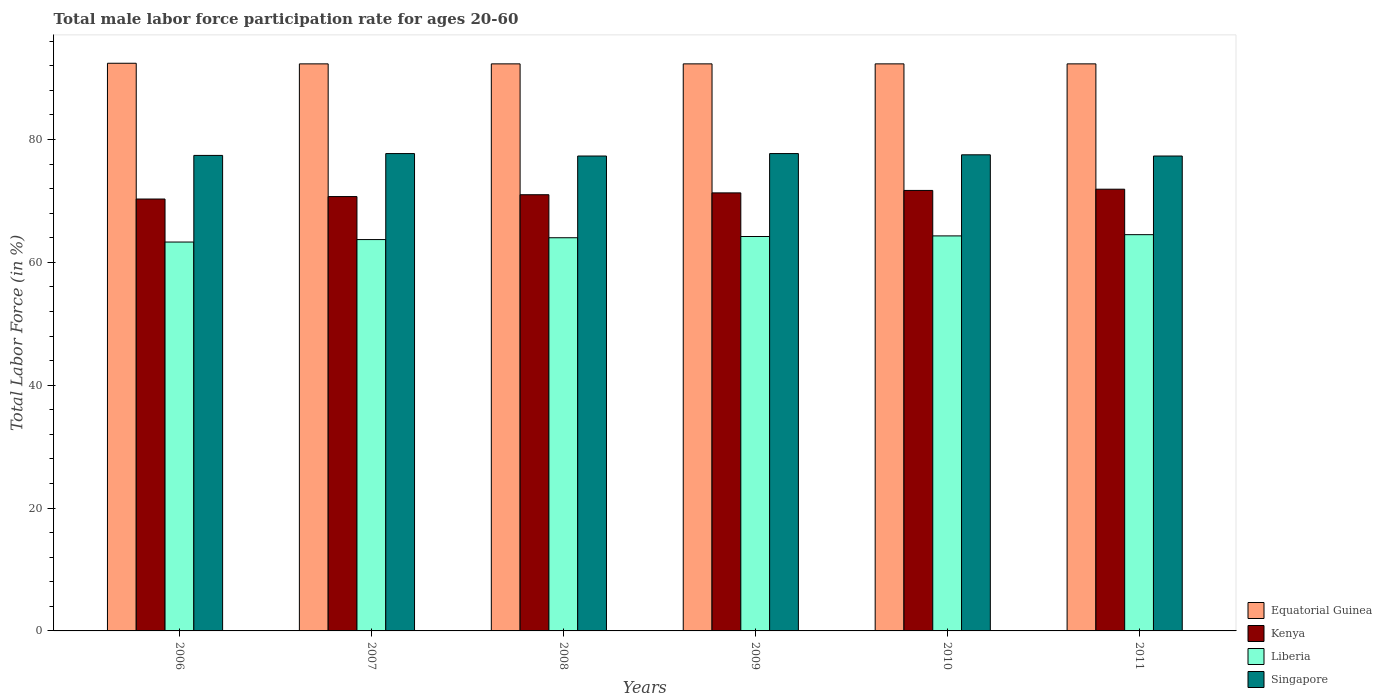How many groups of bars are there?
Keep it short and to the point. 6. Are the number of bars per tick equal to the number of legend labels?
Make the answer very short. Yes. What is the male labor force participation rate in Kenya in 2010?
Your response must be concise. 71.7. Across all years, what is the maximum male labor force participation rate in Kenya?
Keep it short and to the point. 71.9. Across all years, what is the minimum male labor force participation rate in Liberia?
Offer a very short reply. 63.3. In which year was the male labor force participation rate in Equatorial Guinea maximum?
Offer a terse response. 2006. In which year was the male labor force participation rate in Liberia minimum?
Your answer should be compact. 2006. What is the total male labor force participation rate in Kenya in the graph?
Offer a terse response. 426.9. What is the difference between the male labor force participation rate in Liberia in 2007 and the male labor force participation rate in Equatorial Guinea in 2010?
Your answer should be compact. -28.6. What is the average male labor force participation rate in Singapore per year?
Provide a succinct answer. 77.48. In the year 2006, what is the difference between the male labor force participation rate in Kenya and male labor force participation rate in Singapore?
Make the answer very short. -7.1. In how many years, is the male labor force participation rate in Singapore greater than 4 %?
Your answer should be very brief. 6. What is the ratio of the male labor force participation rate in Singapore in 2006 to that in 2011?
Make the answer very short. 1. Is the male labor force participation rate in Singapore in 2006 less than that in 2011?
Your response must be concise. No. Is the difference between the male labor force participation rate in Kenya in 2007 and 2010 greater than the difference between the male labor force participation rate in Singapore in 2007 and 2010?
Make the answer very short. No. What is the difference between the highest and the second highest male labor force participation rate in Equatorial Guinea?
Your response must be concise. 0.1. What is the difference between the highest and the lowest male labor force participation rate in Singapore?
Provide a short and direct response. 0.4. In how many years, is the male labor force participation rate in Singapore greater than the average male labor force participation rate in Singapore taken over all years?
Offer a very short reply. 3. What does the 3rd bar from the left in 2009 represents?
Give a very brief answer. Liberia. What does the 3rd bar from the right in 2007 represents?
Make the answer very short. Kenya. How many bars are there?
Your response must be concise. 24. What is the difference between two consecutive major ticks on the Y-axis?
Provide a short and direct response. 20. Does the graph contain any zero values?
Your answer should be compact. No. Does the graph contain grids?
Your answer should be compact. No. How many legend labels are there?
Provide a short and direct response. 4. How are the legend labels stacked?
Keep it short and to the point. Vertical. What is the title of the graph?
Ensure brevity in your answer.  Total male labor force participation rate for ages 20-60. Does "Tajikistan" appear as one of the legend labels in the graph?
Make the answer very short. No. What is the label or title of the Y-axis?
Keep it short and to the point. Total Labor Force (in %). What is the Total Labor Force (in %) in Equatorial Guinea in 2006?
Your answer should be very brief. 92.4. What is the Total Labor Force (in %) in Kenya in 2006?
Make the answer very short. 70.3. What is the Total Labor Force (in %) of Liberia in 2006?
Provide a short and direct response. 63.3. What is the Total Labor Force (in %) in Singapore in 2006?
Give a very brief answer. 77.4. What is the Total Labor Force (in %) in Equatorial Guinea in 2007?
Give a very brief answer. 92.3. What is the Total Labor Force (in %) in Kenya in 2007?
Your answer should be compact. 70.7. What is the Total Labor Force (in %) of Liberia in 2007?
Make the answer very short. 63.7. What is the Total Labor Force (in %) of Singapore in 2007?
Ensure brevity in your answer.  77.7. What is the Total Labor Force (in %) in Equatorial Guinea in 2008?
Provide a short and direct response. 92.3. What is the Total Labor Force (in %) in Liberia in 2008?
Make the answer very short. 64. What is the Total Labor Force (in %) in Singapore in 2008?
Offer a terse response. 77.3. What is the Total Labor Force (in %) in Equatorial Guinea in 2009?
Provide a short and direct response. 92.3. What is the Total Labor Force (in %) of Kenya in 2009?
Offer a terse response. 71.3. What is the Total Labor Force (in %) in Liberia in 2009?
Give a very brief answer. 64.2. What is the Total Labor Force (in %) of Singapore in 2009?
Your answer should be very brief. 77.7. What is the Total Labor Force (in %) of Equatorial Guinea in 2010?
Make the answer very short. 92.3. What is the Total Labor Force (in %) of Kenya in 2010?
Your answer should be very brief. 71.7. What is the Total Labor Force (in %) of Liberia in 2010?
Your answer should be very brief. 64.3. What is the Total Labor Force (in %) in Singapore in 2010?
Make the answer very short. 77.5. What is the Total Labor Force (in %) in Equatorial Guinea in 2011?
Make the answer very short. 92.3. What is the Total Labor Force (in %) of Kenya in 2011?
Your answer should be compact. 71.9. What is the Total Labor Force (in %) in Liberia in 2011?
Give a very brief answer. 64.5. What is the Total Labor Force (in %) in Singapore in 2011?
Make the answer very short. 77.3. Across all years, what is the maximum Total Labor Force (in %) in Equatorial Guinea?
Your response must be concise. 92.4. Across all years, what is the maximum Total Labor Force (in %) of Kenya?
Provide a succinct answer. 71.9. Across all years, what is the maximum Total Labor Force (in %) of Liberia?
Make the answer very short. 64.5. Across all years, what is the maximum Total Labor Force (in %) of Singapore?
Offer a very short reply. 77.7. Across all years, what is the minimum Total Labor Force (in %) of Equatorial Guinea?
Make the answer very short. 92.3. Across all years, what is the minimum Total Labor Force (in %) in Kenya?
Your answer should be compact. 70.3. Across all years, what is the minimum Total Labor Force (in %) in Liberia?
Provide a short and direct response. 63.3. Across all years, what is the minimum Total Labor Force (in %) of Singapore?
Keep it short and to the point. 77.3. What is the total Total Labor Force (in %) in Equatorial Guinea in the graph?
Your answer should be very brief. 553.9. What is the total Total Labor Force (in %) of Kenya in the graph?
Make the answer very short. 426.9. What is the total Total Labor Force (in %) of Liberia in the graph?
Your answer should be compact. 384. What is the total Total Labor Force (in %) in Singapore in the graph?
Make the answer very short. 464.9. What is the difference between the Total Labor Force (in %) in Liberia in 2006 and that in 2007?
Offer a terse response. -0.4. What is the difference between the Total Labor Force (in %) of Equatorial Guinea in 2006 and that in 2008?
Make the answer very short. 0.1. What is the difference between the Total Labor Force (in %) in Singapore in 2006 and that in 2008?
Make the answer very short. 0.1. What is the difference between the Total Labor Force (in %) in Liberia in 2006 and that in 2009?
Ensure brevity in your answer.  -0.9. What is the difference between the Total Labor Force (in %) in Kenya in 2006 and that in 2010?
Your answer should be very brief. -1.4. What is the difference between the Total Labor Force (in %) in Liberia in 2006 and that in 2010?
Offer a terse response. -1. What is the difference between the Total Labor Force (in %) of Equatorial Guinea in 2006 and that in 2011?
Give a very brief answer. 0.1. What is the difference between the Total Labor Force (in %) in Kenya in 2006 and that in 2011?
Keep it short and to the point. -1.6. What is the difference between the Total Labor Force (in %) of Liberia in 2006 and that in 2011?
Make the answer very short. -1.2. What is the difference between the Total Labor Force (in %) in Singapore in 2006 and that in 2011?
Your response must be concise. 0.1. What is the difference between the Total Labor Force (in %) of Equatorial Guinea in 2007 and that in 2008?
Your answer should be compact. 0. What is the difference between the Total Labor Force (in %) of Kenya in 2007 and that in 2008?
Offer a very short reply. -0.3. What is the difference between the Total Labor Force (in %) of Singapore in 2007 and that in 2009?
Make the answer very short. 0. What is the difference between the Total Labor Force (in %) of Equatorial Guinea in 2007 and that in 2011?
Offer a terse response. 0. What is the difference between the Total Labor Force (in %) in Singapore in 2007 and that in 2011?
Give a very brief answer. 0.4. What is the difference between the Total Labor Force (in %) in Kenya in 2008 and that in 2009?
Provide a short and direct response. -0.3. What is the difference between the Total Labor Force (in %) of Singapore in 2008 and that in 2009?
Offer a terse response. -0.4. What is the difference between the Total Labor Force (in %) of Kenya in 2008 and that in 2010?
Offer a very short reply. -0.7. What is the difference between the Total Labor Force (in %) in Singapore in 2008 and that in 2010?
Keep it short and to the point. -0.2. What is the difference between the Total Labor Force (in %) of Equatorial Guinea in 2008 and that in 2011?
Keep it short and to the point. 0. What is the difference between the Total Labor Force (in %) of Singapore in 2008 and that in 2011?
Your answer should be compact. 0. What is the difference between the Total Labor Force (in %) in Kenya in 2009 and that in 2010?
Make the answer very short. -0.4. What is the difference between the Total Labor Force (in %) of Liberia in 2009 and that in 2010?
Make the answer very short. -0.1. What is the difference between the Total Labor Force (in %) of Singapore in 2009 and that in 2010?
Make the answer very short. 0.2. What is the difference between the Total Labor Force (in %) in Equatorial Guinea in 2009 and that in 2011?
Your answer should be very brief. 0. What is the difference between the Total Labor Force (in %) in Singapore in 2009 and that in 2011?
Give a very brief answer. 0.4. What is the difference between the Total Labor Force (in %) in Equatorial Guinea in 2010 and that in 2011?
Make the answer very short. 0. What is the difference between the Total Labor Force (in %) of Liberia in 2010 and that in 2011?
Your answer should be compact. -0.2. What is the difference between the Total Labor Force (in %) in Singapore in 2010 and that in 2011?
Your response must be concise. 0.2. What is the difference between the Total Labor Force (in %) in Equatorial Guinea in 2006 and the Total Labor Force (in %) in Kenya in 2007?
Your answer should be compact. 21.7. What is the difference between the Total Labor Force (in %) of Equatorial Guinea in 2006 and the Total Labor Force (in %) of Liberia in 2007?
Give a very brief answer. 28.7. What is the difference between the Total Labor Force (in %) of Kenya in 2006 and the Total Labor Force (in %) of Liberia in 2007?
Provide a succinct answer. 6.6. What is the difference between the Total Labor Force (in %) in Liberia in 2006 and the Total Labor Force (in %) in Singapore in 2007?
Offer a terse response. -14.4. What is the difference between the Total Labor Force (in %) of Equatorial Guinea in 2006 and the Total Labor Force (in %) of Kenya in 2008?
Keep it short and to the point. 21.4. What is the difference between the Total Labor Force (in %) in Equatorial Guinea in 2006 and the Total Labor Force (in %) in Liberia in 2008?
Keep it short and to the point. 28.4. What is the difference between the Total Labor Force (in %) of Kenya in 2006 and the Total Labor Force (in %) of Liberia in 2008?
Provide a short and direct response. 6.3. What is the difference between the Total Labor Force (in %) of Liberia in 2006 and the Total Labor Force (in %) of Singapore in 2008?
Offer a very short reply. -14. What is the difference between the Total Labor Force (in %) in Equatorial Guinea in 2006 and the Total Labor Force (in %) in Kenya in 2009?
Offer a very short reply. 21.1. What is the difference between the Total Labor Force (in %) in Equatorial Guinea in 2006 and the Total Labor Force (in %) in Liberia in 2009?
Provide a succinct answer. 28.2. What is the difference between the Total Labor Force (in %) of Liberia in 2006 and the Total Labor Force (in %) of Singapore in 2009?
Make the answer very short. -14.4. What is the difference between the Total Labor Force (in %) in Equatorial Guinea in 2006 and the Total Labor Force (in %) in Kenya in 2010?
Provide a succinct answer. 20.7. What is the difference between the Total Labor Force (in %) of Equatorial Guinea in 2006 and the Total Labor Force (in %) of Liberia in 2010?
Keep it short and to the point. 28.1. What is the difference between the Total Labor Force (in %) in Equatorial Guinea in 2006 and the Total Labor Force (in %) in Kenya in 2011?
Your answer should be very brief. 20.5. What is the difference between the Total Labor Force (in %) of Equatorial Guinea in 2006 and the Total Labor Force (in %) of Liberia in 2011?
Keep it short and to the point. 27.9. What is the difference between the Total Labor Force (in %) in Kenya in 2006 and the Total Labor Force (in %) in Liberia in 2011?
Provide a succinct answer. 5.8. What is the difference between the Total Labor Force (in %) in Kenya in 2006 and the Total Labor Force (in %) in Singapore in 2011?
Keep it short and to the point. -7. What is the difference between the Total Labor Force (in %) in Equatorial Guinea in 2007 and the Total Labor Force (in %) in Kenya in 2008?
Offer a terse response. 21.3. What is the difference between the Total Labor Force (in %) in Equatorial Guinea in 2007 and the Total Labor Force (in %) in Liberia in 2008?
Your response must be concise. 28.3. What is the difference between the Total Labor Force (in %) of Kenya in 2007 and the Total Labor Force (in %) of Singapore in 2008?
Offer a very short reply. -6.6. What is the difference between the Total Labor Force (in %) in Liberia in 2007 and the Total Labor Force (in %) in Singapore in 2008?
Your response must be concise. -13.6. What is the difference between the Total Labor Force (in %) of Equatorial Guinea in 2007 and the Total Labor Force (in %) of Liberia in 2009?
Your answer should be compact. 28.1. What is the difference between the Total Labor Force (in %) of Liberia in 2007 and the Total Labor Force (in %) of Singapore in 2009?
Offer a very short reply. -14. What is the difference between the Total Labor Force (in %) of Equatorial Guinea in 2007 and the Total Labor Force (in %) of Kenya in 2010?
Provide a succinct answer. 20.6. What is the difference between the Total Labor Force (in %) in Liberia in 2007 and the Total Labor Force (in %) in Singapore in 2010?
Provide a short and direct response. -13.8. What is the difference between the Total Labor Force (in %) in Equatorial Guinea in 2007 and the Total Labor Force (in %) in Kenya in 2011?
Keep it short and to the point. 20.4. What is the difference between the Total Labor Force (in %) in Equatorial Guinea in 2007 and the Total Labor Force (in %) in Liberia in 2011?
Your answer should be compact. 27.8. What is the difference between the Total Labor Force (in %) in Equatorial Guinea in 2007 and the Total Labor Force (in %) in Singapore in 2011?
Your response must be concise. 15. What is the difference between the Total Labor Force (in %) in Kenya in 2007 and the Total Labor Force (in %) in Singapore in 2011?
Provide a short and direct response. -6.6. What is the difference between the Total Labor Force (in %) in Liberia in 2007 and the Total Labor Force (in %) in Singapore in 2011?
Make the answer very short. -13.6. What is the difference between the Total Labor Force (in %) in Equatorial Guinea in 2008 and the Total Labor Force (in %) in Kenya in 2009?
Make the answer very short. 21. What is the difference between the Total Labor Force (in %) of Equatorial Guinea in 2008 and the Total Labor Force (in %) of Liberia in 2009?
Your answer should be very brief. 28.1. What is the difference between the Total Labor Force (in %) in Kenya in 2008 and the Total Labor Force (in %) in Liberia in 2009?
Your answer should be very brief. 6.8. What is the difference between the Total Labor Force (in %) of Liberia in 2008 and the Total Labor Force (in %) of Singapore in 2009?
Offer a terse response. -13.7. What is the difference between the Total Labor Force (in %) in Equatorial Guinea in 2008 and the Total Labor Force (in %) in Kenya in 2010?
Provide a short and direct response. 20.6. What is the difference between the Total Labor Force (in %) of Equatorial Guinea in 2008 and the Total Labor Force (in %) of Liberia in 2010?
Offer a very short reply. 28. What is the difference between the Total Labor Force (in %) in Kenya in 2008 and the Total Labor Force (in %) in Liberia in 2010?
Provide a succinct answer. 6.7. What is the difference between the Total Labor Force (in %) in Kenya in 2008 and the Total Labor Force (in %) in Singapore in 2010?
Your answer should be very brief. -6.5. What is the difference between the Total Labor Force (in %) in Liberia in 2008 and the Total Labor Force (in %) in Singapore in 2010?
Keep it short and to the point. -13.5. What is the difference between the Total Labor Force (in %) of Equatorial Guinea in 2008 and the Total Labor Force (in %) of Kenya in 2011?
Ensure brevity in your answer.  20.4. What is the difference between the Total Labor Force (in %) of Equatorial Guinea in 2008 and the Total Labor Force (in %) of Liberia in 2011?
Your answer should be compact. 27.8. What is the difference between the Total Labor Force (in %) of Equatorial Guinea in 2008 and the Total Labor Force (in %) of Singapore in 2011?
Offer a very short reply. 15. What is the difference between the Total Labor Force (in %) of Kenya in 2008 and the Total Labor Force (in %) of Liberia in 2011?
Give a very brief answer. 6.5. What is the difference between the Total Labor Force (in %) in Equatorial Guinea in 2009 and the Total Labor Force (in %) in Kenya in 2010?
Ensure brevity in your answer.  20.6. What is the difference between the Total Labor Force (in %) of Equatorial Guinea in 2009 and the Total Labor Force (in %) of Liberia in 2010?
Offer a very short reply. 28. What is the difference between the Total Labor Force (in %) of Kenya in 2009 and the Total Labor Force (in %) of Liberia in 2010?
Offer a terse response. 7. What is the difference between the Total Labor Force (in %) in Kenya in 2009 and the Total Labor Force (in %) in Singapore in 2010?
Give a very brief answer. -6.2. What is the difference between the Total Labor Force (in %) of Liberia in 2009 and the Total Labor Force (in %) of Singapore in 2010?
Your answer should be very brief. -13.3. What is the difference between the Total Labor Force (in %) in Equatorial Guinea in 2009 and the Total Labor Force (in %) in Kenya in 2011?
Provide a succinct answer. 20.4. What is the difference between the Total Labor Force (in %) of Equatorial Guinea in 2009 and the Total Labor Force (in %) of Liberia in 2011?
Your answer should be compact. 27.8. What is the difference between the Total Labor Force (in %) in Kenya in 2009 and the Total Labor Force (in %) in Liberia in 2011?
Your answer should be compact. 6.8. What is the difference between the Total Labor Force (in %) in Kenya in 2009 and the Total Labor Force (in %) in Singapore in 2011?
Offer a very short reply. -6. What is the difference between the Total Labor Force (in %) in Equatorial Guinea in 2010 and the Total Labor Force (in %) in Kenya in 2011?
Your answer should be very brief. 20.4. What is the difference between the Total Labor Force (in %) in Equatorial Guinea in 2010 and the Total Labor Force (in %) in Liberia in 2011?
Your response must be concise. 27.8. What is the average Total Labor Force (in %) in Equatorial Guinea per year?
Give a very brief answer. 92.32. What is the average Total Labor Force (in %) of Kenya per year?
Provide a succinct answer. 71.15. What is the average Total Labor Force (in %) of Singapore per year?
Provide a short and direct response. 77.48. In the year 2006, what is the difference between the Total Labor Force (in %) in Equatorial Guinea and Total Labor Force (in %) in Kenya?
Provide a short and direct response. 22.1. In the year 2006, what is the difference between the Total Labor Force (in %) of Equatorial Guinea and Total Labor Force (in %) of Liberia?
Provide a succinct answer. 29.1. In the year 2006, what is the difference between the Total Labor Force (in %) in Equatorial Guinea and Total Labor Force (in %) in Singapore?
Offer a very short reply. 15. In the year 2006, what is the difference between the Total Labor Force (in %) in Kenya and Total Labor Force (in %) in Liberia?
Your response must be concise. 7. In the year 2006, what is the difference between the Total Labor Force (in %) in Liberia and Total Labor Force (in %) in Singapore?
Your response must be concise. -14.1. In the year 2007, what is the difference between the Total Labor Force (in %) in Equatorial Guinea and Total Labor Force (in %) in Kenya?
Provide a succinct answer. 21.6. In the year 2007, what is the difference between the Total Labor Force (in %) of Equatorial Guinea and Total Labor Force (in %) of Liberia?
Keep it short and to the point. 28.6. In the year 2007, what is the difference between the Total Labor Force (in %) of Kenya and Total Labor Force (in %) of Liberia?
Make the answer very short. 7. In the year 2007, what is the difference between the Total Labor Force (in %) of Kenya and Total Labor Force (in %) of Singapore?
Your answer should be very brief. -7. In the year 2008, what is the difference between the Total Labor Force (in %) in Equatorial Guinea and Total Labor Force (in %) in Kenya?
Ensure brevity in your answer.  21.3. In the year 2008, what is the difference between the Total Labor Force (in %) of Equatorial Guinea and Total Labor Force (in %) of Liberia?
Provide a short and direct response. 28.3. In the year 2008, what is the difference between the Total Labor Force (in %) in Equatorial Guinea and Total Labor Force (in %) in Singapore?
Your response must be concise. 15. In the year 2008, what is the difference between the Total Labor Force (in %) of Liberia and Total Labor Force (in %) of Singapore?
Provide a short and direct response. -13.3. In the year 2009, what is the difference between the Total Labor Force (in %) of Equatorial Guinea and Total Labor Force (in %) of Liberia?
Your answer should be compact. 28.1. In the year 2009, what is the difference between the Total Labor Force (in %) of Kenya and Total Labor Force (in %) of Liberia?
Provide a short and direct response. 7.1. In the year 2009, what is the difference between the Total Labor Force (in %) of Kenya and Total Labor Force (in %) of Singapore?
Provide a short and direct response. -6.4. In the year 2009, what is the difference between the Total Labor Force (in %) in Liberia and Total Labor Force (in %) in Singapore?
Keep it short and to the point. -13.5. In the year 2010, what is the difference between the Total Labor Force (in %) in Equatorial Guinea and Total Labor Force (in %) in Kenya?
Make the answer very short. 20.6. In the year 2010, what is the difference between the Total Labor Force (in %) of Equatorial Guinea and Total Labor Force (in %) of Liberia?
Keep it short and to the point. 28. In the year 2011, what is the difference between the Total Labor Force (in %) in Equatorial Guinea and Total Labor Force (in %) in Kenya?
Ensure brevity in your answer.  20.4. In the year 2011, what is the difference between the Total Labor Force (in %) of Equatorial Guinea and Total Labor Force (in %) of Liberia?
Provide a short and direct response. 27.8. In the year 2011, what is the difference between the Total Labor Force (in %) of Equatorial Guinea and Total Labor Force (in %) of Singapore?
Keep it short and to the point. 15. In the year 2011, what is the difference between the Total Labor Force (in %) in Kenya and Total Labor Force (in %) in Singapore?
Make the answer very short. -5.4. What is the ratio of the Total Labor Force (in %) of Kenya in 2006 to that in 2007?
Make the answer very short. 0.99. What is the ratio of the Total Labor Force (in %) in Singapore in 2006 to that in 2007?
Ensure brevity in your answer.  1. What is the ratio of the Total Labor Force (in %) of Equatorial Guinea in 2006 to that in 2008?
Ensure brevity in your answer.  1. What is the ratio of the Total Labor Force (in %) in Kenya in 2006 to that in 2008?
Keep it short and to the point. 0.99. What is the ratio of the Total Labor Force (in %) of Liberia in 2006 to that in 2009?
Offer a terse response. 0.99. What is the ratio of the Total Labor Force (in %) of Equatorial Guinea in 2006 to that in 2010?
Give a very brief answer. 1. What is the ratio of the Total Labor Force (in %) of Kenya in 2006 to that in 2010?
Your response must be concise. 0.98. What is the ratio of the Total Labor Force (in %) in Liberia in 2006 to that in 2010?
Offer a terse response. 0.98. What is the ratio of the Total Labor Force (in %) in Kenya in 2006 to that in 2011?
Provide a succinct answer. 0.98. What is the ratio of the Total Labor Force (in %) in Liberia in 2006 to that in 2011?
Ensure brevity in your answer.  0.98. What is the ratio of the Total Labor Force (in %) in Kenya in 2007 to that in 2008?
Your response must be concise. 1. What is the ratio of the Total Labor Force (in %) in Equatorial Guinea in 2007 to that in 2009?
Your answer should be compact. 1. What is the ratio of the Total Labor Force (in %) in Equatorial Guinea in 2007 to that in 2010?
Keep it short and to the point. 1. What is the ratio of the Total Labor Force (in %) of Kenya in 2007 to that in 2010?
Provide a short and direct response. 0.99. What is the ratio of the Total Labor Force (in %) of Singapore in 2007 to that in 2010?
Your answer should be very brief. 1. What is the ratio of the Total Labor Force (in %) of Equatorial Guinea in 2007 to that in 2011?
Provide a succinct answer. 1. What is the ratio of the Total Labor Force (in %) of Kenya in 2007 to that in 2011?
Offer a very short reply. 0.98. What is the ratio of the Total Labor Force (in %) of Liberia in 2007 to that in 2011?
Provide a short and direct response. 0.99. What is the ratio of the Total Labor Force (in %) in Liberia in 2008 to that in 2009?
Your response must be concise. 1. What is the ratio of the Total Labor Force (in %) in Kenya in 2008 to that in 2010?
Your response must be concise. 0.99. What is the ratio of the Total Labor Force (in %) in Liberia in 2008 to that in 2010?
Offer a terse response. 1. What is the ratio of the Total Labor Force (in %) of Kenya in 2008 to that in 2011?
Provide a short and direct response. 0.99. What is the ratio of the Total Labor Force (in %) in Singapore in 2008 to that in 2011?
Provide a succinct answer. 1. What is the ratio of the Total Labor Force (in %) in Equatorial Guinea in 2009 to that in 2010?
Make the answer very short. 1. What is the ratio of the Total Labor Force (in %) in Liberia in 2009 to that in 2010?
Ensure brevity in your answer.  1. What is the ratio of the Total Labor Force (in %) in Kenya in 2009 to that in 2011?
Ensure brevity in your answer.  0.99. What is the ratio of the Total Labor Force (in %) in Liberia in 2009 to that in 2011?
Provide a short and direct response. 1. What is the ratio of the Total Labor Force (in %) in Singapore in 2009 to that in 2011?
Give a very brief answer. 1.01. What is the ratio of the Total Labor Force (in %) of Equatorial Guinea in 2010 to that in 2011?
Your answer should be very brief. 1. What is the ratio of the Total Labor Force (in %) in Kenya in 2010 to that in 2011?
Keep it short and to the point. 1. What is the ratio of the Total Labor Force (in %) in Singapore in 2010 to that in 2011?
Ensure brevity in your answer.  1. What is the difference between the highest and the second highest Total Labor Force (in %) in Equatorial Guinea?
Keep it short and to the point. 0.1. What is the difference between the highest and the second highest Total Labor Force (in %) in Liberia?
Your answer should be compact. 0.2. What is the difference between the highest and the second highest Total Labor Force (in %) of Singapore?
Ensure brevity in your answer.  0. What is the difference between the highest and the lowest Total Labor Force (in %) in Singapore?
Provide a succinct answer. 0.4. 